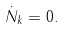<formula> <loc_0><loc_0><loc_500><loc_500>\dot { N } _ { k } = 0 .</formula> 